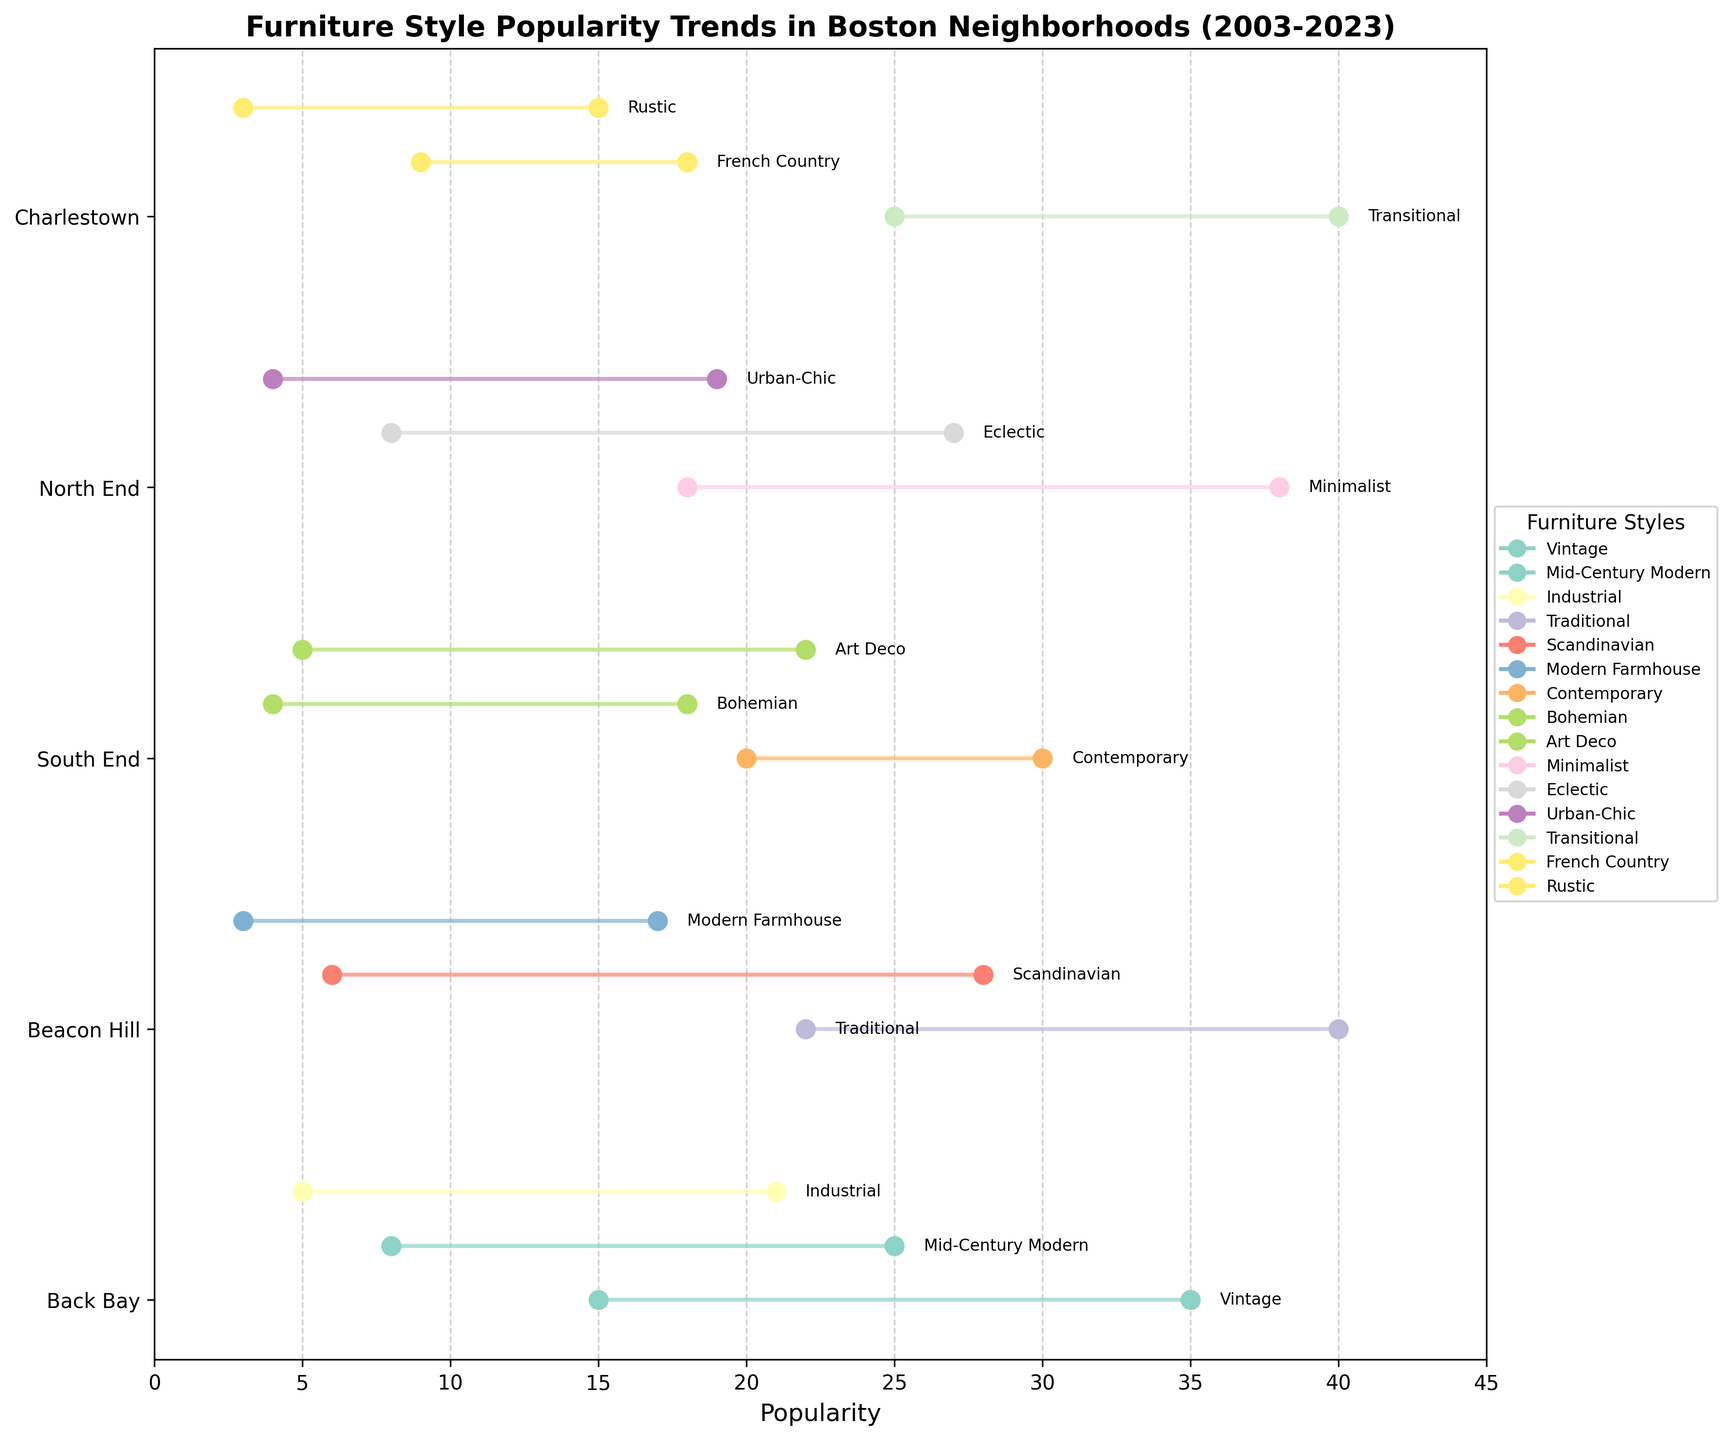Which neighborhood has the highest popularity for a furniture style in 2023? The neighborhood with the highest popularity must have the highest 2023 value on the x-axis. By comparing the ending points of the lines on the plot, "North End" with 38 for "Minimalist" is the highest.
Answer: North End Which furniture style in Beacon Hill had the largest drop in popularity from 2003 to 2023? Calculate the difference in popularity for each style in Beacon Hill by checking the start and end values of lines. The biggest drop is for "Traditional," which went from 40 to 22 (a decrease of 18).
Answer: Traditional How did the popularity of "Scandinavian" style change in Beacon Hill from 2013 to 2023? Look at the data points for "Scandinavian" in Beacon Hill, noting the position of the dots in 2013 and 2023. It went from 15 to 28.
Answer: Increased Which neighborhood has the most diverse range of furniture styles in terms of popularity trends? Count the distinct styles within each neighborhood and examine the variation in trends (line lengths and directions). South End has the most varied range with "Contemporary," "Bohemian," and "Art Deco," all showing various trends.
Answer: South End What is the average popularity of "Mid-Century Modern" in Back Bay for the years shown? Add up the "Mid-Century Modern" popularity values for 2003, 2013, and 2023 in Back Bay and divide by the number of years. (0 + 8 + 18 + 25) / 3 = 17
Answer: 17 Which furniture styles have notably risen in popularity the most across any neighborhood? Identify the styles with the longest upward lines across all neighborhoods. "Minimalist" in North End (from 18 to 38) and "Scandinavian" in Beacon Hill (from 6 to 28) show significant rises.
Answer: Minimalist, Scandinavian What trend in popularity did the "Industrial" style in Back Bay show between 2008 and 2023? Look at the 2008 starting values and follow the line to 2023. It rises continuously from 5 to 21.
Answer: Increased steadily How do the popularity trends of "Transitional" and "French Country" styles compare in Charlestown? Compare the start and end values of their lines: "Transitional" starts at 25 (2003) and goes to 40 (2023), while "French Country" starts at 9 (2006) and reaches 18 (2023). Both increased, but "Transitional" had a more significant rise.
Answer: Transitional increased more What is the most popular furniture style in South End in 2023? Look at the endpoints for all styles in South End and identify the highest value: "Contemporary" reaches 30 in 2023.
Answer: Contemporary Between which years did "Bohemian" style in South End show the most significant increase in popularity? Look at the change from starting points to 2023 for "Bohemian." The largest change occurred from 2007 when it was introduced to 2013. It increased from approximately 4 to 18.
Answer: Between 2007 and 2023 